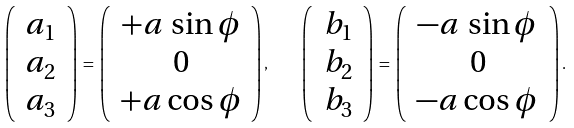Convert formula to latex. <formula><loc_0><loc_0><loc_500><loc_500>\left ( \, \begin{array} { c } a _ { 1 } \\ a _ { 2 } \\ a _ { 3 } \end{array} \, \right ) \, = \, \left ( \, \begin{array} { c } + a \, \sin \phi \\ 0 \\ + a \cos \phi \end{array} \right ) , \quad \left ( \, \begin{array} { c } b _ { 1 } \\ b _ { 2 } \\ b _ { 3 } \end{array} \, \right ) \, = \, \left ( \, \begin{array} { c } - a \, \sin \phi \\ 0 \\ - a \cos \phi \end{array} \, \right ) .</formula> 